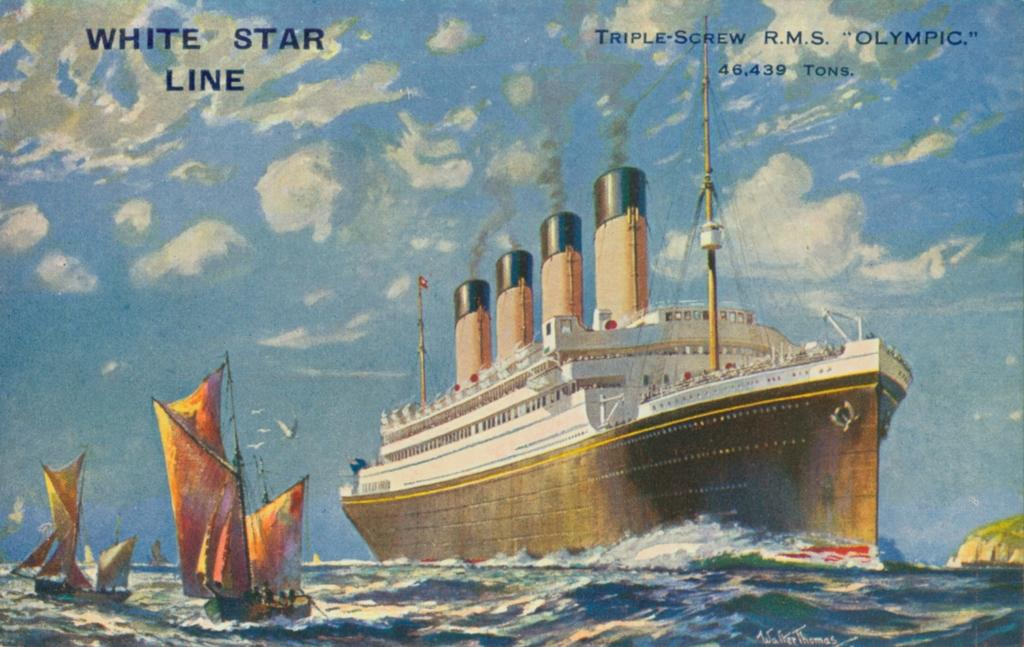What type of watercraft is the main subject in the image? There is a ferry on the water in the image. Are there any other watercrafts visible in the image? Yes, there are boats beside the ferry in the image. Is there any text or image present in the image related to the ferry or boats? Yes, there is text or an image written above the ferry or boats in the image. Can you describe the servant's attire in the image? There is no servant present in the image; it features a ferry and boats on the water. 